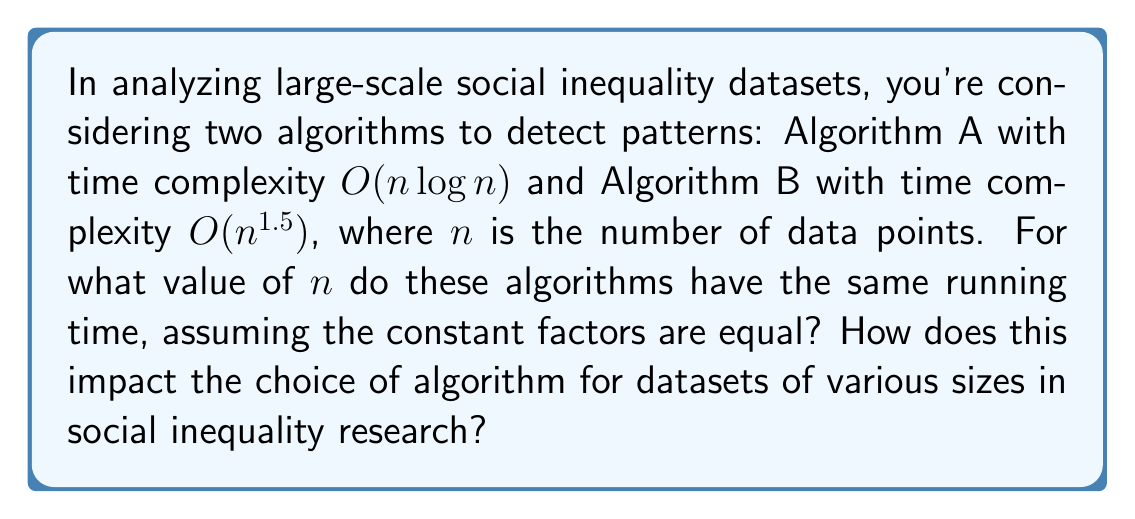Show me your answer to this math problem. To solve this problem, we need to follow these steps:

1) Set up an equation where both time complexities are equal:

   $c_1 \cdot n \log n = c_2 \cdot n^{1.5}$

   Where $c_1$ and $c_2$ are constant factors. Since we're assuming these are equal, we can simplify:

   $n \log n = n^{1.5}$

2) Divide both sides by $n$:

   $\log n = n^{0.5} = \sqrt{n}$

3) Square both sides:

   $(\log n)^2 = n$

4) Apply the exponential function to both sides:

   $n = e^{(\log n)^2}$

5) This equation doesn't have a closed-form solution, but we can solve it numerically. Using computational methods, we find that:

   $n \approx 65,536 = 2^{16}$

This result has important implications for social inequality research:

- For datasets with fewer than 65,536 data points, Algorithm A ($O(n \log n)$) will be more efficient.
- For datasets with more than 65,536 data points, Algorithm B ($O(n^{1.5})$) will be more efficient.

In the context of social inequality studies, this means:

- For smaller scale studies (e.g., community-level or small demographic groups), Algorithm A would be preferable.
- For large-scale national or global studies involving millions of data points, Algorithm B would be more efficient despite its higher complexity for small n.

This analysis helps researchers choose the most appropriate algorithm based on their dataset size, ensuring optimal computational efficiency in detecting patterns of social inequality.
Answer: The algorithms have the same running time when $n \approx 65,536$. For $n < 65,536$, Algorithm A ($O(n \log n)$) is more efficient; for $n > 65,536$, Algorithm B ($O(n^{1.5})$) is more efficient. 